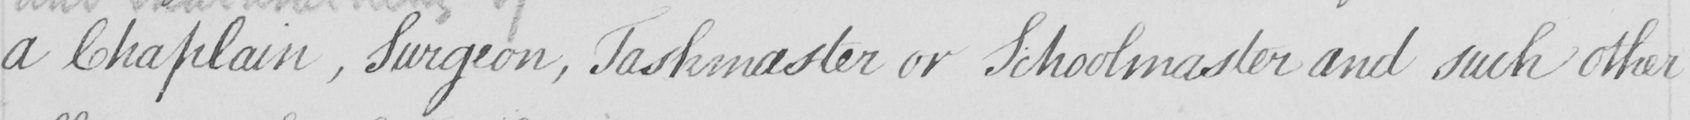Please transcribe the handwritten text in this image. a Chaplain , Surgeon , Taskmaster or Schoolmaster and such other 